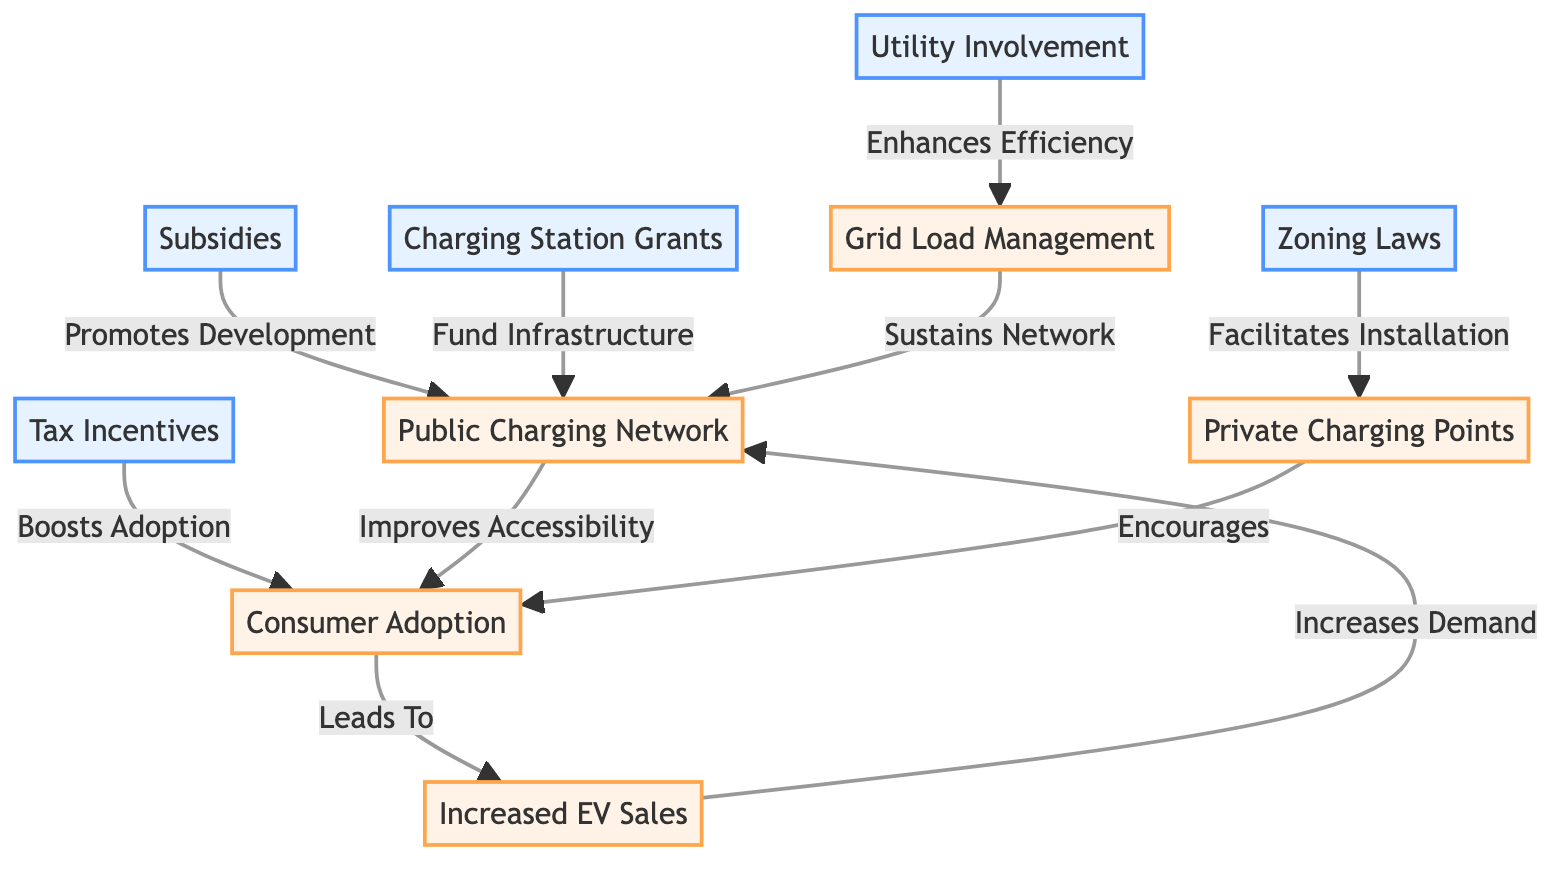How many policy nodes are in the diagram? The diagram lists several nodes, and by counting them, we find there are five policy nodes: subsidies, tax incentives, zoning laws, charging station grants, and utility involvement.
Answer: 5 Which node is influenced by zoning laws? Looking at the arrow connections, zoning laws facilitate the installation of private charging points, therefore it directly influences the private charging points node.
Answer: Private Charging Points What is the relationship between tax incentives and consumer adoption? The arrow pointing from tax incentives to consumer adoption indicates that tax incentives boost consumer adoption, thus showing a direct positive relationship between these two nodes.
Answer: Boosts Adoption Which outcome is linked to increased EV sales? The diagram shows that increased EV sales leads to a growing public charging network, establishing a direct connection from increased EV sales to the public charging network node.
Answer: Public Charging Network What node does utility involvement enhance efficiency for? The edge from utility involvement is directed towards the grid load management node, indicating that utility involvement enhances efficiency specifically for grid load management.
Answer: Grid Load Management If consumer adoption increases, what effect does it have on increased EV sales? According to the diagram, consumer adoption leads to increased EV sales, indicating that higher consumer adoption results in more electric vehicle sales.
Answer: Leads To What funding mechanism contributes to the public charging network? The diagram shows two mechanisms; however, charging station grants specifically fund the public charging network, making it a primary funding source for that node.
Answer: Charging Station Grants What two nodes contribute to consumer adoption? The diagram demonstrates that both the public charging network and private charging points encourage consumer adoption, indicating a dual influence from these two nodes.
Answer: Public Charging Network and Private Charging Points How does grid load management sustain the network? The arrow indicates that grid load management sustains the public charging network, showing that effective grid load management is essential for keeping the network operational.
Answer: Sustains Network 